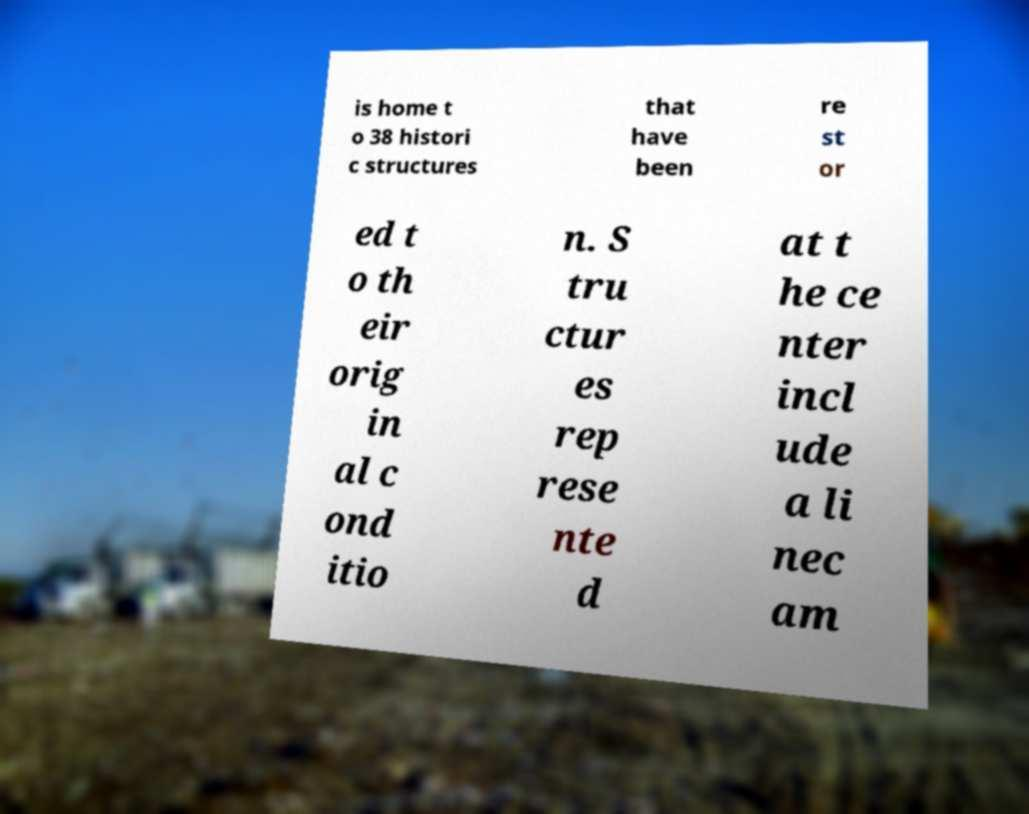Can you read and provide the text displayed in the image?This photo seems to have some interesting text. Can you extract and type it out for me? is home t o 38 histori c structures that have been re st or ed t o th eir orig in al c ond itio n. S tru ctur es rep rese nte d at t he ce nter incl ude a li nec am 